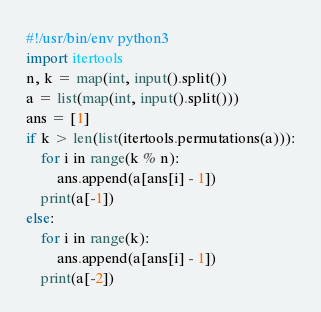Convert code to text. <code><loc_0><loc_0><loc_500><loc_500><_Python_>#!/usr/bin/env python3
import itertools
n, k = map(int, input().split())
a = list(map(int, input().split()))
ans = [1]
if k > len(list(itertools.permutations(a))):
    for i in range(k % n):
        ans.append(a[ans[i] - 1])
    print(a[-1])
else:
    for i in range(k):
        ans.append(a[ans[i] - 1])
    print(a[-2])    
</code> 